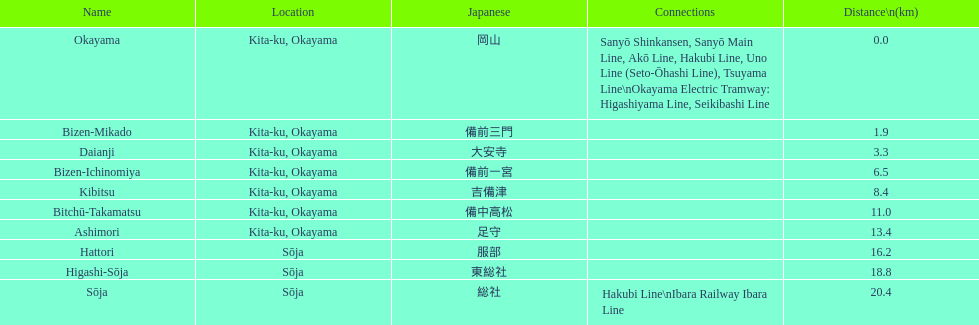Which has the most distance, hattori or kibitsu? Hattori. 